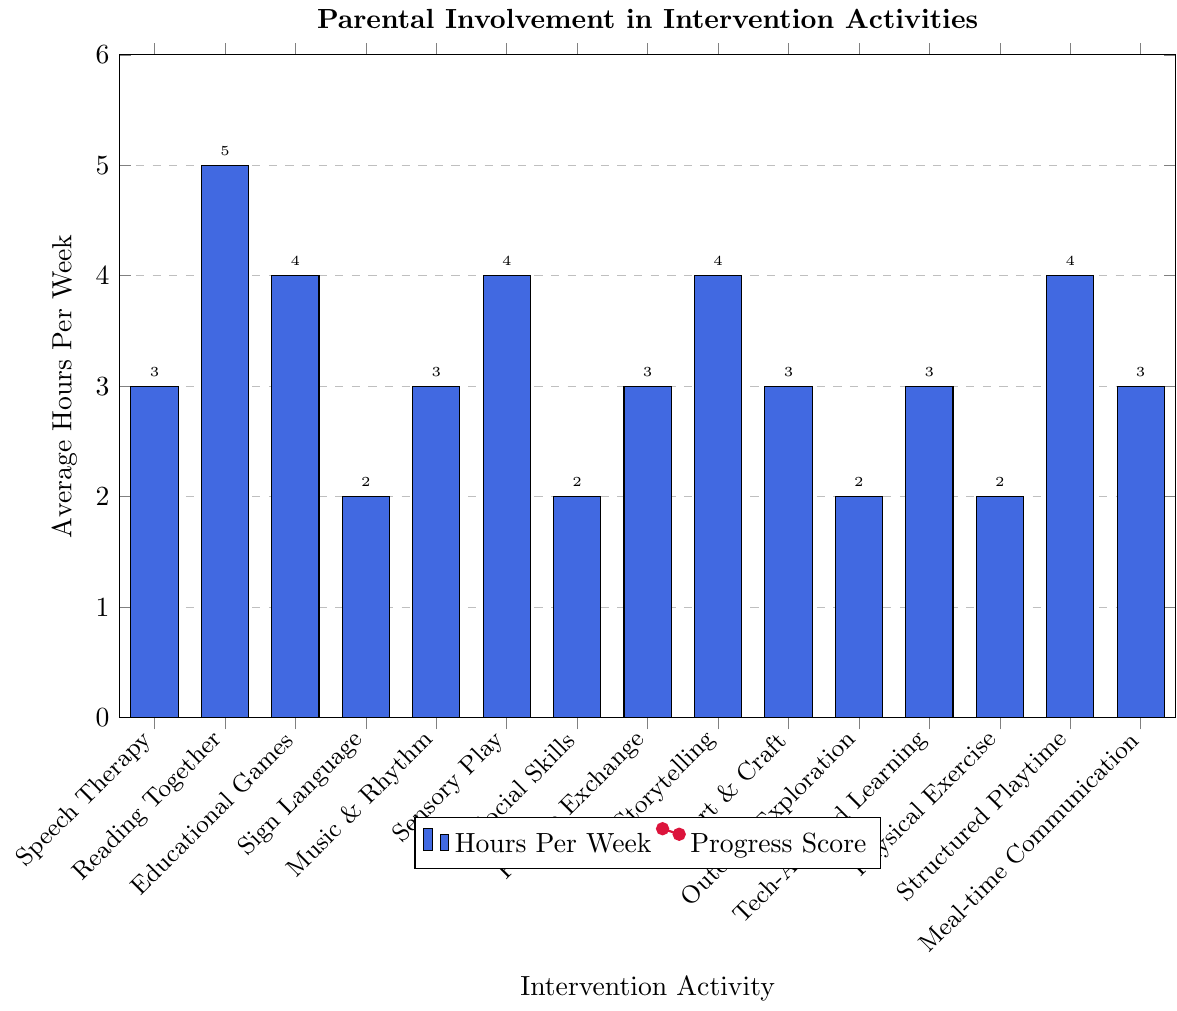What's the intervention activity with the highest average hours per week? Reading Together has the highest bar height on the plot, indicating the maximum average hours per week among all activities.
Answer: Reading Together Which intervention activity has the highest progress score? Reading Together has the highest point on the red line, indicating the highest progress score.
Answer: Reading Together What is the difference in average hours per week between Speech Therapy Sessions and Social Skills Training? Speech Therapy Sessions have an average of 3 hours per week and Social Skills Training has an average of 2 hours per week. The difference is 3 - 2 = 1 hour.
Answer: 1 hour Which activity that involves 4 hours per week has the highest progress score, and what is that score? Among activities with 4 hours per week (Educational Games, Sensory Play, Storytelling and Narration, Structured Playtime), Storytelling and Narration has the highest progress score of 79.
Answer: Storytelling and Narration, 79 How many intervention activities have both average hours per week and progress score greater than 70? List them. Reading Together, Educational Games, Sensory Play, Storytelling and Narration, and Structured Playtime each have more than 2 hours per week and a progress score greater than 70.
Answer: 5: Reading Together, Educational Games, Sensory Play, Storytelling and Narration, Structured Playtime What is the average progress score for activities that involve 3 hours per week? Activities involving 3 hours per week are Speech Therapy Sessions, Music and Rhythm Activities, Picture Exchange Communication, Art and Craft Activities, Technology-Assisted Learning, and Meal-time Communication Practice. Their progress scores are 75, 73, 72, 70, 74, and 71, respectively. The average is (75 + 73 + 72 + 70 + 74 + 71)/6 = 72.5.
Answer: 72.5 Compare the progress scores of Sign Language Practice and Technology-Assisted Learning. Which is higher and by how much? Sign Language Practice has a progress score of 68, and Technology-Assisted Learning has a score of 74. The difference is 74 - 68 = 6.
Answer: Technology-Assisted Learning, 6 Which intervention activity paired with its average hours has the closest value to 70 in progress score? Meal-time Communication Practice has an average of 3 hours per week and a progress score closest to 70, which is exactly 71.
Answer: Meal-time Communication Practice Calculate the sum of average hours per week for all intervention activities. Summing the average hours per week: 3 + 5 + 4 + 2 + 3 + 4 + 2 + 3 + 4 + 3 + 2 + 3 + 2 + 4 + 3 = 43.
Answer: 43 